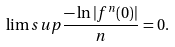Convert formula to latex. <formula><loc_0><loc_0><loc_500><loc_500>\lim s u p \frac { - \ln | f ^ { n } ( 0 ) | } { n } = 0 .</formula> 